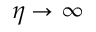<formula> <loc_0><loc_0><loc_500><loc_500>\eta \to \infty</formula> 